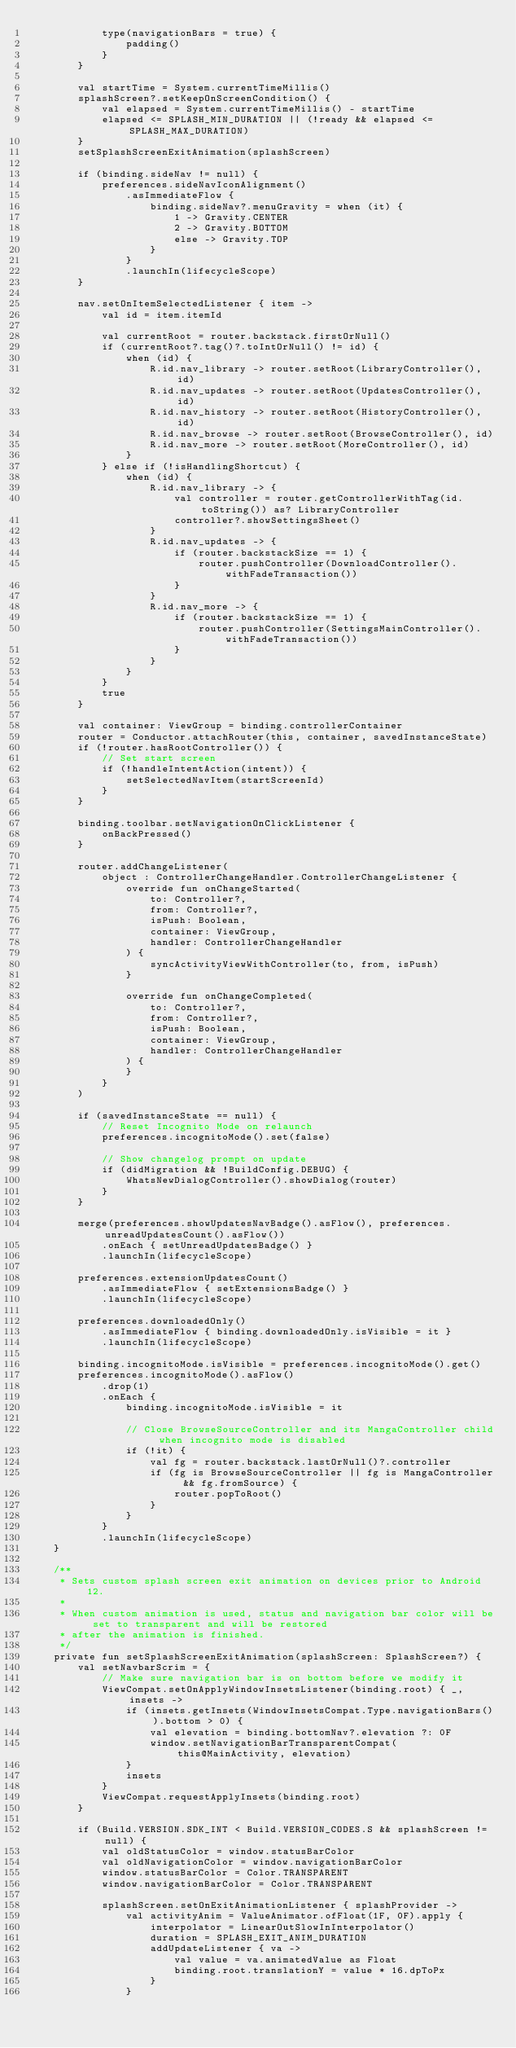Convert code to text. <code><loc_0><loc_0><loc_500><loc_500><_Kotlin_>            type(navigationBars = true) {
                padding()
            }
        }

        val startTime = System.currentTimeMillis()
        splashScreen?.setKeepOnScreenCondition() {
            val elapsed = System.currentTimeMillis() - startTime
            elapsed <= SPLASH_MIN_DURATION || (!ready && elapsed <= SPLASH_MAX_DURATION)
        }
        setSplashScreenExitAnimation(splashScreen)

        if (binding.sideNav != null) {
            preferences.sideNavIconAlignment()
                .asImmediateFlow {
                    binding.sideNav?.menuGravity = when (it) {
                        1 -> Gravity.CENTER
                        2 -> Gravity.BOTTOM
                        else -> Gravity.TOP
                    }
                }
                .launchIn(lifecycleScope)
        }

        nav.setOnItemSelectedListener { item ->
            val id = item.itemId

            val currentRoot = router.backstack.firstOrNull()
            if (currentRoot?.tag()?.toIntOrNull() != id) {
                when (id) {
                    R.id.nav_library -> router.setRoot(LibraryController(), id)
                    R.id.nav_updates -> router.setRoot(UpdatesController(), id)
                    R.id.nav_history -> router.setRoot(HistoryController(), id)
                    R.id.nav_browse -> router.setRoot(BrowseController(), id)
                    R.id.nav_more -> router.setRoot(MoreController(), id)
                }
            } else if (!isHandlingShortcut) {
                when (id) {
                    R.id.nav_library -> {
                        val controller = router.getControllerWithTag(id.toString()) as? LibraryController
                        controller?.showSettingsSheet()
                    }
                    R.id.nav_updates -> {
                        if (router.backstackSize == 1) {
                            router.pushController(DownloadController().withFadeTransaction())
                        }
                    }
                    R.id.nav_more -> {
                        if (router.backstackSize == 1) {
                            router.pushController(SettingsMainController().withFadeTransaction())
                        }
                    }
                }
            }
            true
        }

        val container: ViewGroup = binding.controllerContainer
        router = Conductor.attachRouter(this, container, savedInstanceState)
        if (!router.hasRootController()) {
            // Set start screen
            if (!handleIntentAction(intent)) {
                setSelectedNavItem(startScreenId)
            }
        }

        binding.toolbar.setNavigationOnClickListener {
            onBackPressed()
        }

        router.addChangeListener(
            object : ControllerChangeHandler.ControllerChangeListener {
                override fun onChangeStarted(
                    to: Controller?,
                    from: Controller?,
                    isPush: Boolean,
                    container: ViewGroup,
                    handler: ControllerChangeHandler
                ) {
                    syncActivityViewWithController(to, from, isPush)
                }

                override fun onChangeCompleted(
                    to: Controller?,
                    from: Controller?,
                    isPush: Boolean,
                    container: ViewGroup,
                    handler: ControllerChangeHandler
                ) {
                }
            }
        )

        if (savedInstanceState == null) {
            // Reset Incognito Mode on relaunch
            preferences.incognitoMode().set(false)

            // Show changelog prompt on update
            if (didMigration && !BuildConfig.DEBUG) {
                WhatsNewDialogController().showDialog(router)
            }
        }

        merge(preferences.showUpdatesNavBadge().asFlow(), preferences.unreadUpdatesCount().asFlow())
            .onEach { setUnreadUpdatesBadge() }
            .launchIn(lifecycleScope)

        preferences.extensionUpdatesCount()
            .asImmediateFlow { setExtensionsBadge() }
            .launchIn(lifecycleScope)

        preferences.downloadedOnly()
            .asImmediateFlow { binding.downloadedOnly.isVisible = it }
            .launchIn(lifecycleScope)

        binding.incognitoMode.isVisible = preferences.incognitoMode().get()
        preferences.incognitoMode().asFlow()
            .drop(1)
            .onEach {
                binding.incognitoMode.isVisible = it

                // Close BrowseSourceController and its MangaController child when incognito mode is disabled
                if (!it) {
                    val fg = router.backstack.lastOrNull()?.controller
                    if (fg is BrowseSourceController || fg is MangaController && fg.fromSource) {
                        router.popToRoot()
                    }
                }
            }
            .launchIn(lifecycleScope)
    }

    /**
     * Sets custom splash screen exit animation on devices prior to Android 12.
     *
     * When custom animation is used, status and navigation bar color will be set to transparent and will be restored
     * after the animation is finished.
     */
    private fun setSplashScreenExitAnimation(splashScreen: SplashScreen?) {
        val setNavbarScrim = {
            // Make sure navigation bar is on bottom before we modify it
            ViewCompat.setOnApplyWindowInsetsListener(binding.root) { _, insets ->
                if (insets.getInsets(WindowInsetsCompat.Type.navigationBars()).bottom > 0) {
                    val elevation = binding.bottomNav?.elevation ?: 0F
                    window.setNavigationBarTransparentCompat(this@MainActivity, elevation)
                }
                insets
            }
            ViewCompat.requestApplyInsets(binding.root)
        }

        if (Build.VERSION.SDK_INT < Build.VERSION_CODES.S && splashScreen != null) {
            val oldStatusColor = window.statusBarColor
            val oldNavigationColor = window.navigationBarColor
            window.statusBarColor = Color.TRANSPARENT
            window.navigationBarColor = Color.TRANSPARENT

            splashScreen.setOnExitAnimationListener { splashProvider ->
                val activityAnim = ValueAnimator.ofFloat(1F, 0F).apply {
                    interpolator = LinearOutSlowInInterpolator()
                    duration = SPLASH_EXIT_ANIM_DURATION
                    addUpdateListener { va ->
                        val value = va.animatedValue as Float
                        binding.root.translationY = value * 16.dpToPx
                    }
                }
</code> 